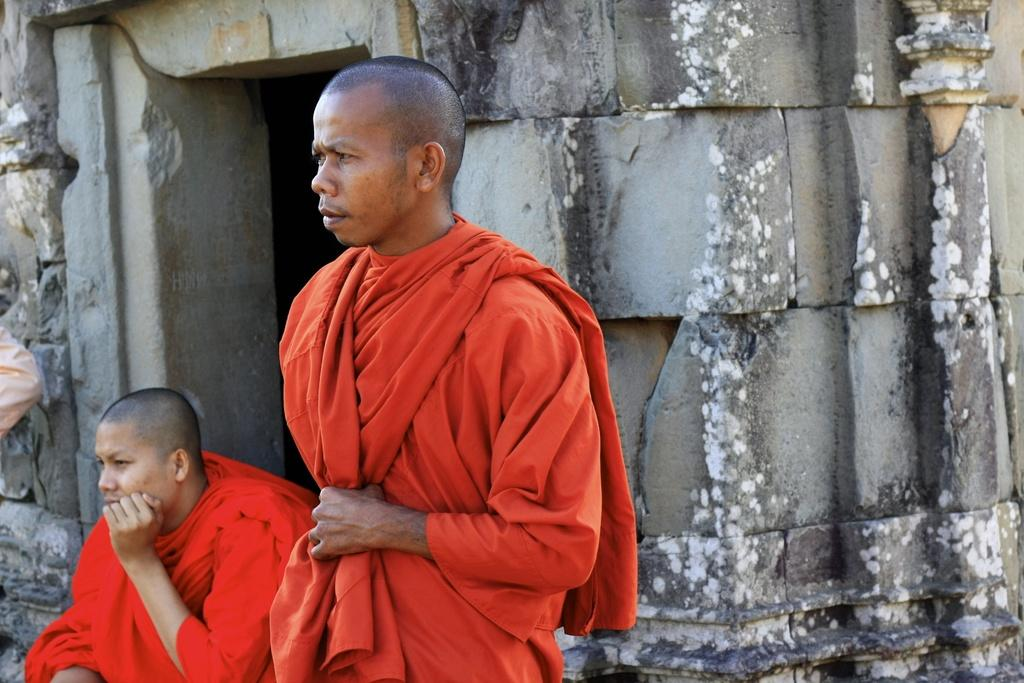How many persons can be seen in the image? There are persons in the image, but the exact number is not specified. What can be seen in the background of the image? There is an entrance and a wall visible in the background of the image. Can you describe the location of the person on the left side of the image? On the left side of the image, it appears that there is a person. What type of street can be seen in the image? There is no street visible in the image. How does the air circulate in the image? The image does not provide any information about air circulation. 